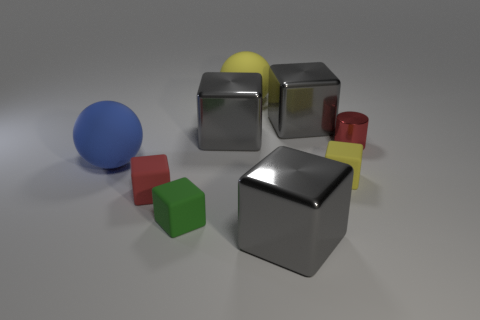Can you tell which of these objects might be heavier based on their appearance? The larger, silver cube in the center appears to be the heaviest due to its size and solid metallic appearance. In comparison, the smaller shapes, such as the green cube or the blue sphere, may be lighter, assuming they are made from the same material as their size is considerably less. 